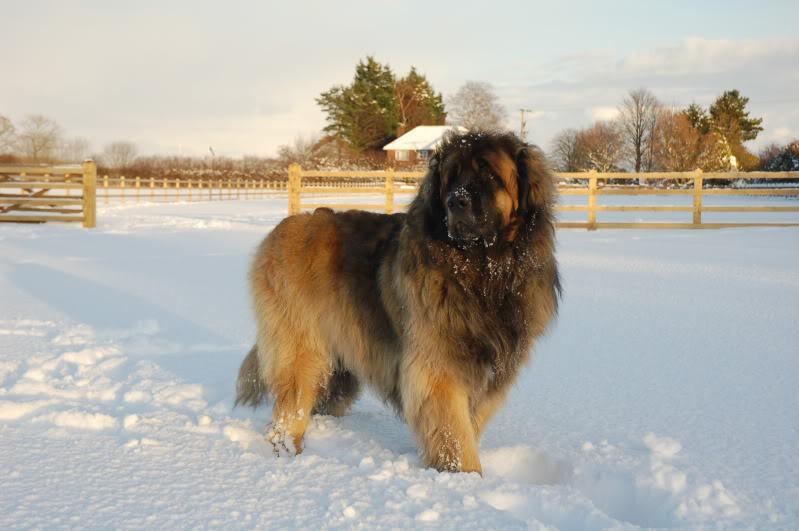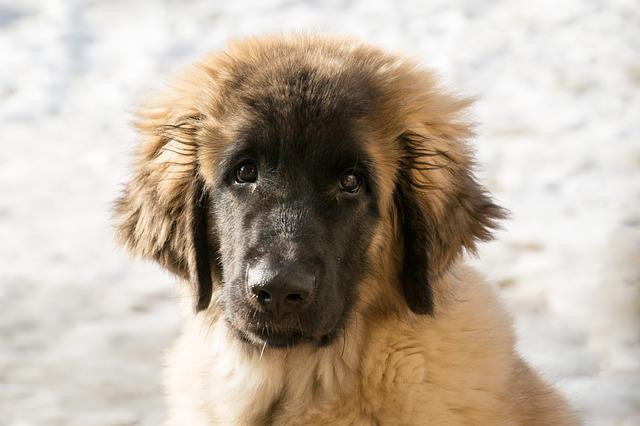The first image is the image on the left, the second image is the image on the right. Considering the images on both sides, is "No image contains a grassy ground, and at least one image contains a dog standing upright on snow." valid? Answer yes or no. Yes. The first image is the image on the left, the second image is the image on the right. Examine the images to the left and right. Is the description "One of the images shows a single dog standing in snow." accurate? Answer yes or no. Yes. 